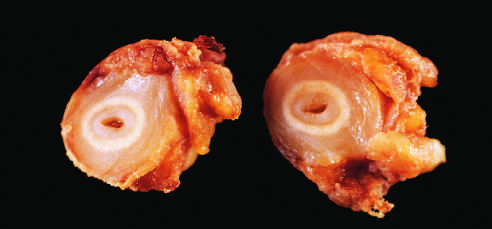s the inner core of tan tissue the area of intimal hyperplasia?
Answer the question using a single word or phrase. Yes 